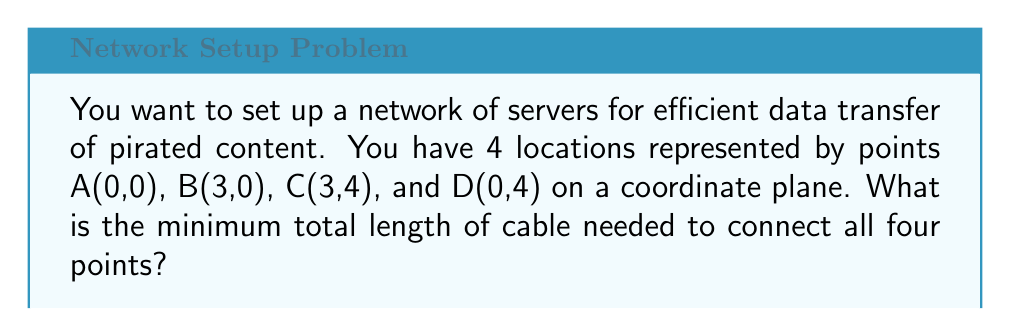What is the answer to this math problem? To solve this problem, we need to find the shortest path that connects all four points. This is known as the minimum spanning tree problem.

Step 1: Visualize the points on a coordinate plane.
[asy]
unitsize(1cm);
pair A=(0,0), B=(3,0), C=(3,4), D=(0,4);
dot("A",A,SW);
dot("B",B,SE);
dot("C",C,NE);
dot("D",D,NW);
draw(A--B--C--D--cycle);
[/asy]

Step 2: Calculate all possible distances between points using the distance formula:
$d = \sqrt{(x_2-x_1)^2 + (y_2-y_1)^2}$

AB = BC = $\sqrt{3^2 + 0^2} = 3$
AD = DC = $\sqrt{0^2 + 4^2} = 4$
AC = BD = $\sqrt{3^2 + 4^2} = 5$

Step 3: Identify the shortest connections that link all points.
The shortest combination is AB + BC + CD, which forms a "U" shape.

Step 4: Calculate the total length of the minimum spanning tree.
Total length = AB + BC + CD = 3 + 4 + 3 = 10

Therefore, the minimum total length of cable needed is 10 units.
Answer: 10 units 